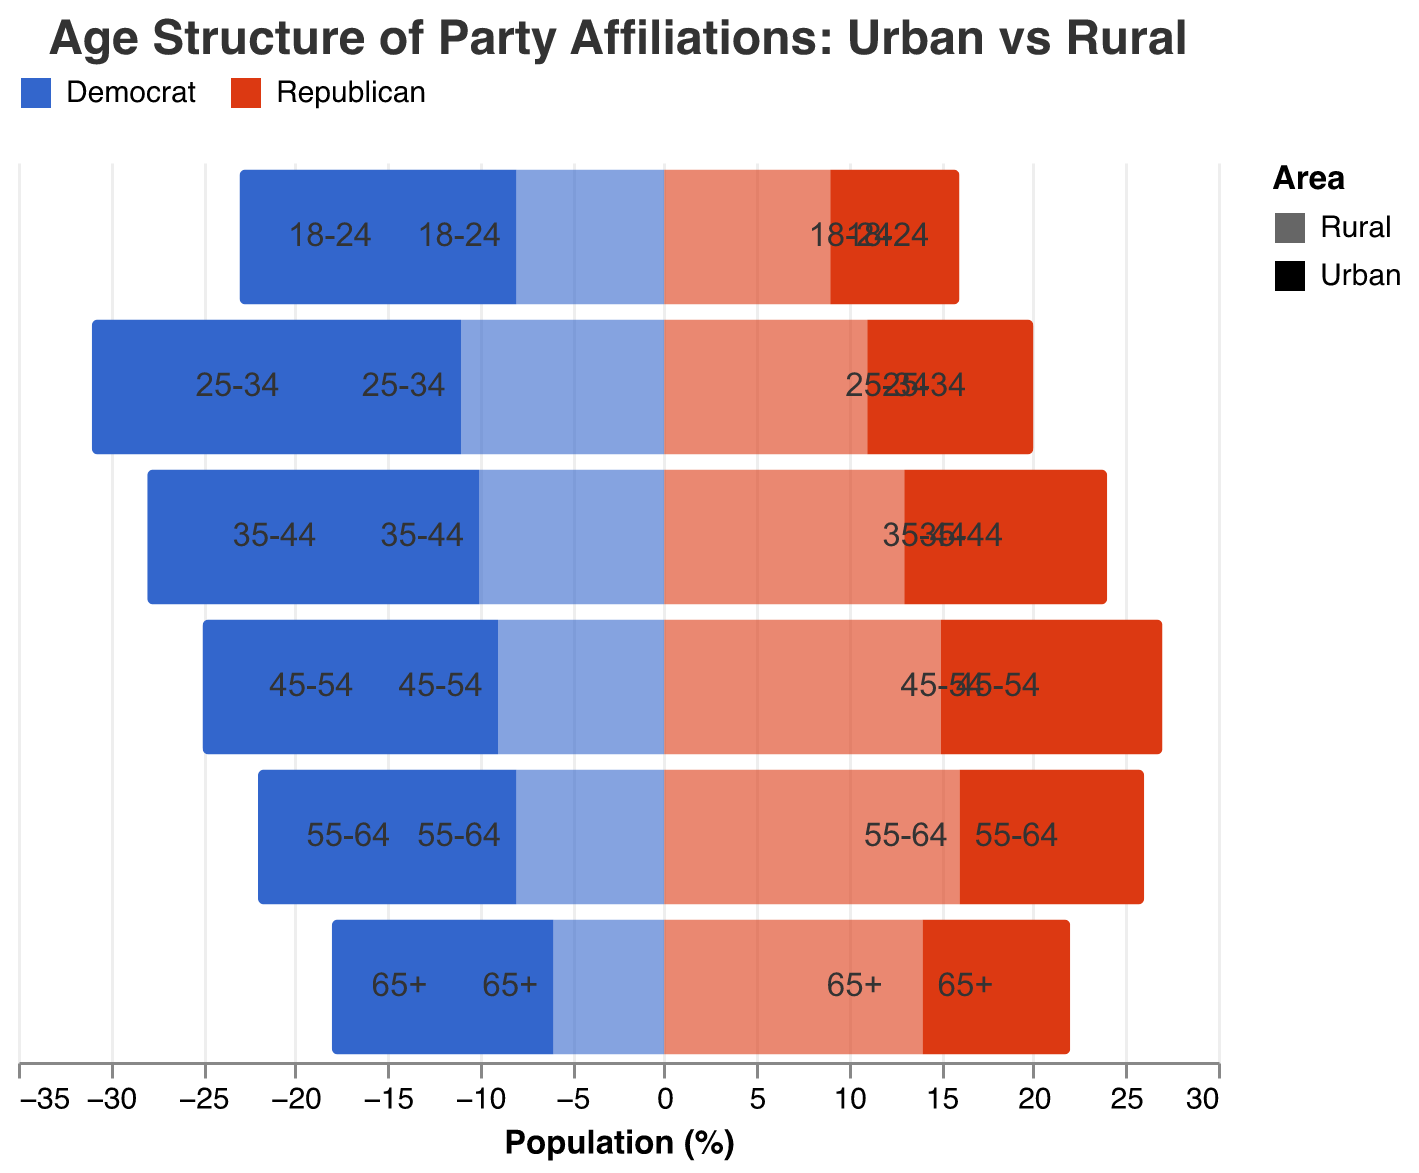what is the title of the figure? The title is typically found at the top of the figure. It provides an overview of what the figure represents. In this case, the title is "Age Structure of Party Affiliations: Urban vs Rural."
Answer: Age Structure of Party Affiliations: Urban vs Rural Which age group has the highest percentage of Urban Democrats? To find this, look at the blue bars on the Urban side and identify the age group with the highest value. The 25-34 age group has the highest percentage of Urban Democrats at 20%.
Answer: 25-34 What is the total percentage of Republicans (Urban and Rural) in the 55-64 age group? Add the percentage of Urban Republicans (10%) and Rural Republicans (16%) for the 55-64 age group to get the total.
Answer: 26% Compare the percentage of Rural Democrats and Rural Republicans in the 65+ age group. Which is higher and by how much? The percentage of Rural Republicans (14%) is higher than that of Rural Democrats (6%) in the 65+ age group. The difference is 14% - 6%, which equals 8%.
Answer: Rural Republicans are higher by 8% Which area (Urban or Rural) has more consistent Democrat support across all age groups? Look at the blue bars for both Urban and Rural Democrats. Urban Democrats have a more consistent and higher percentage across all age groups compared to Rural Democrats.
Answer: Urban What is the difference in percentage points between Urban and Rural Republicans in the 35-44 age group? Subtract the percentage of Urban Republicans (11%) from Rural Republicans (13%) in the 35-44 age group. The difference is 13% - 11% = 2%.
Answer: 2% How do the Urban Republican percentages change from the 18-24 to the 25-34 age group? Compare the percentage of Urban Republicans in the 18-24 age group (7%) with that in the 25-34 age group (9%). The percentage increases by 2 percentage points.
Answer: Increases by 2% Which political party has a higher percentage in the Rural area for the 45-54 age group? Compare the red bars representing Rural Republicans (15%) with the blue bars representing Rural Democrats (9%) in the 45-54 age group. Rural Republicans have a higher percentage.
Answer: Republican Is there any age group where both Urban and Rural Democrats have the same percentage? Check if there is any age group where the blue bars for both Urban and Rural Democrats are equal. In the 25-34 age group, Urban Democrats have 20% and Rural Democrats have 11%, so there is no age group with equal percentages for both.
Answer: No What trend can you observe in the percentage of Urban Democrats across different age groups? Urban Democrats start at 15% in the 18-24 age group, increase to 20% in the 25-34 age group, and then slightly decrease or remain steady in higher age groups. This suggests stronger support among younger urban populations.
Answer: Stronger among younger 